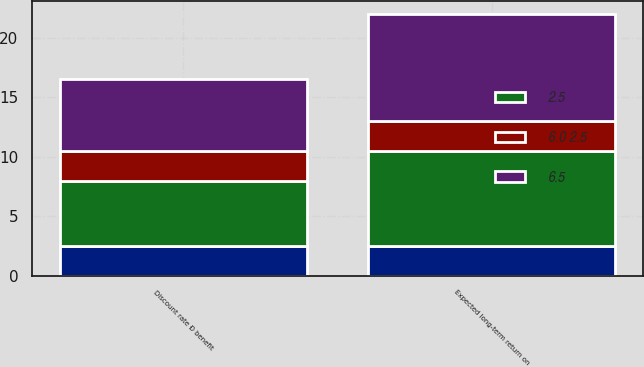Convert chart. <chart><loc_0><loc_0><loc_500><loc_500><stacked_bar_chart><ecel><fcel>Discount rate Ð benefit<fcel>Expected long-term return on<nl><fcel>nan<fcel>2.5<fcel>2.5<nl><fcel>2.5<fcel>5.5<fcel>8<nl><fcel>6.0 2.5<fcel>2.5<fcel>2.5<nl><fcel>6.5<fcel>6<fcel>9<nl></chart> 